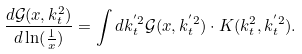<formula> <loc_0><loc_0><loc_500><loc_500>\frac { d \mathcal { G } ( x , k _ { t } ^ { 2 } ) } { d \ln ( \frac { 1 } { x } ) } = \int d k _ { t } ^ { ^ { \prime } 2 } \mathcal { G } ( x , k _ { t } ^ { ^ { \prime } 2 } ) \cdot K ( k _ { t } ^ { 2 } , k _ { t } ^ { ^ { \prime } 2 } ) .</formula> 